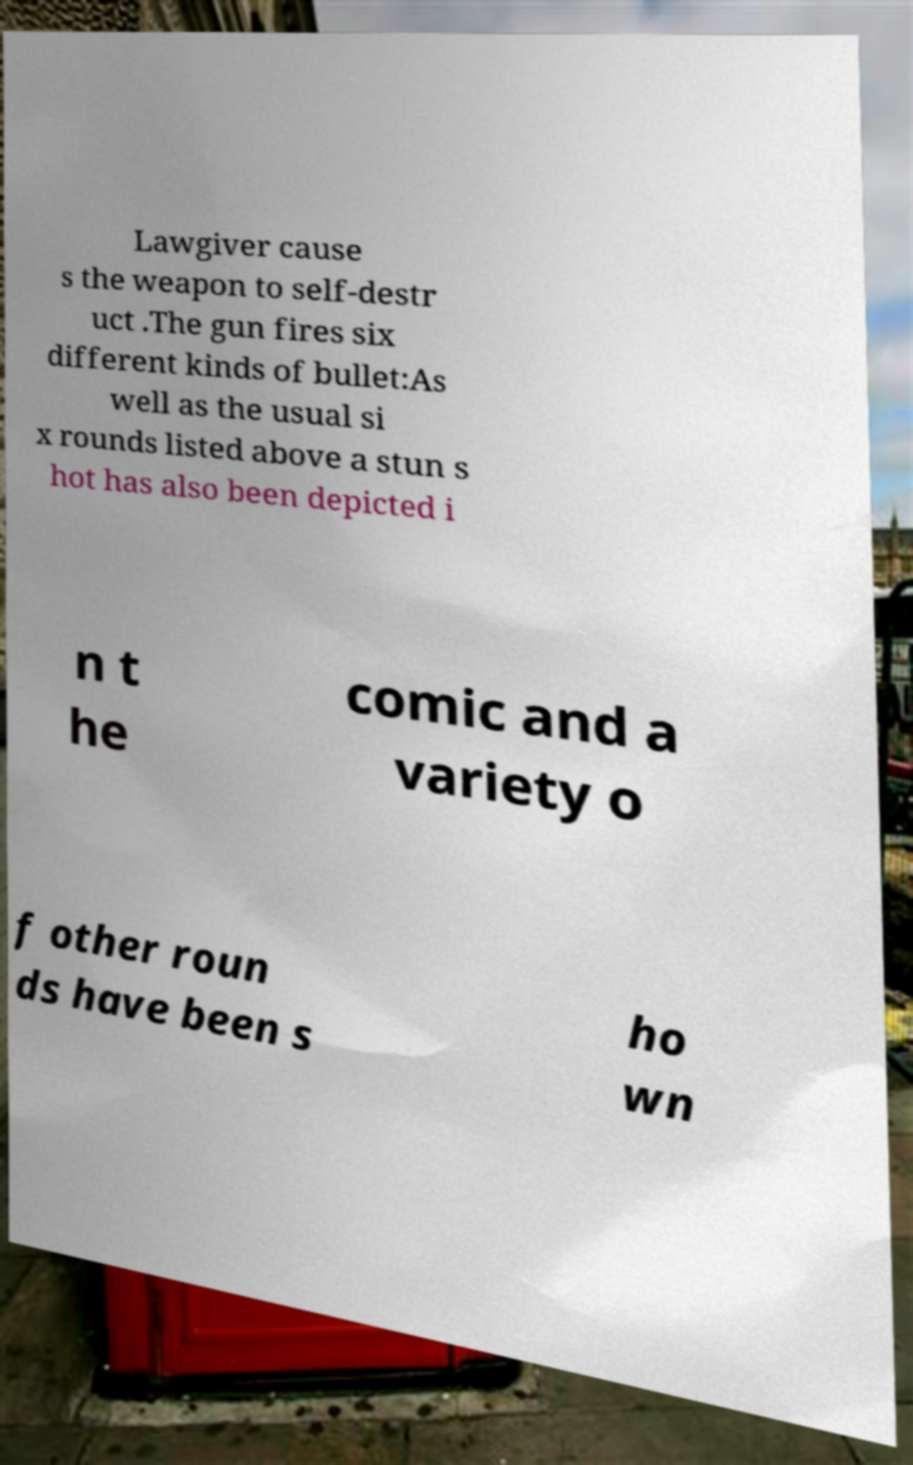Can you accurately transcribe the text from the provided image for me? Lawgiver cause s the weapon to self-destr uct .The gun fires six different kinds of bullet:As well as the usual si x rounds listed above a stun s hot has also been depicted i n t he comic and a variety o f other roun ds have been s ho wn 